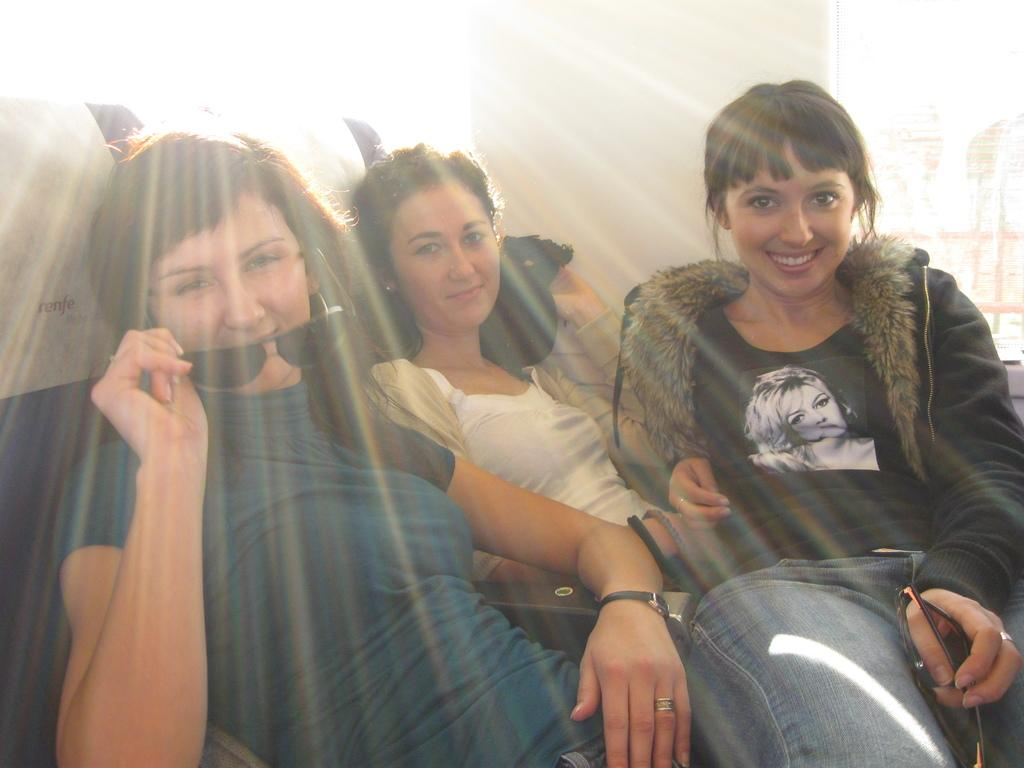How many people are in the foreground of the image? There are three women in the foreground of the image. What are the women doing in the image? The women are posing for a photo. What can be seen in the background of the image? The provided facts do not mention anything about the background of the image. What is the source of light in the image? Sun rays are falling on the women from behind. How many children are holding a letter in the image? There are no children or letters present in the image. Is there an arch visible in the image? There is no mention of an arch in the provided facts, so it cannot be determined if one is present in the image. 